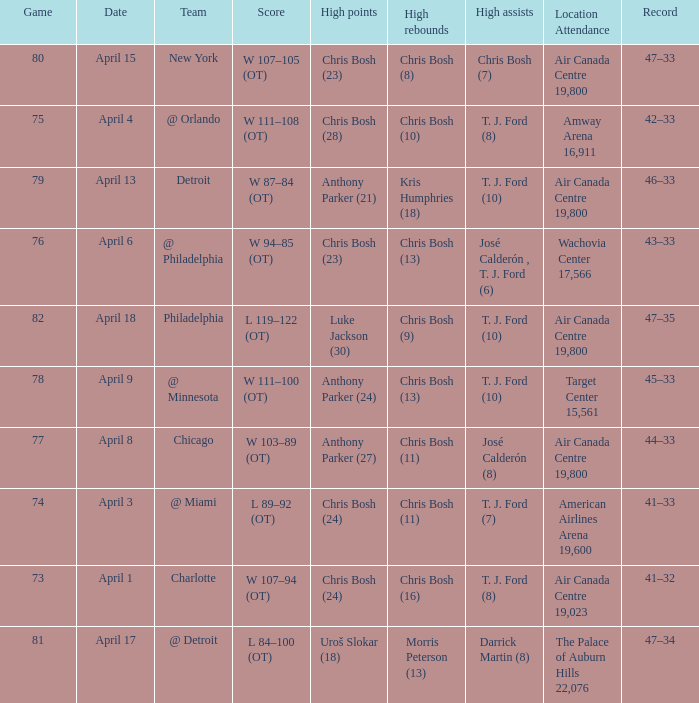What were the assists on April 8 in game less than 78? José Calderón (8). 